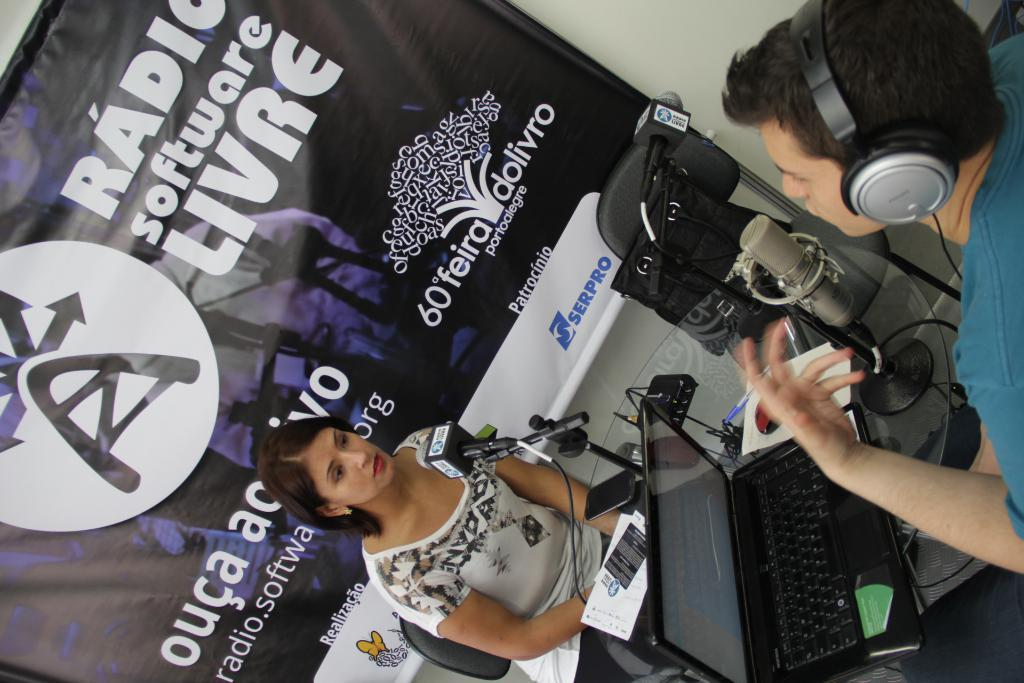<image>
Give a short and clear explanation of the subsequent image. a lady with a ouca sign behind her 